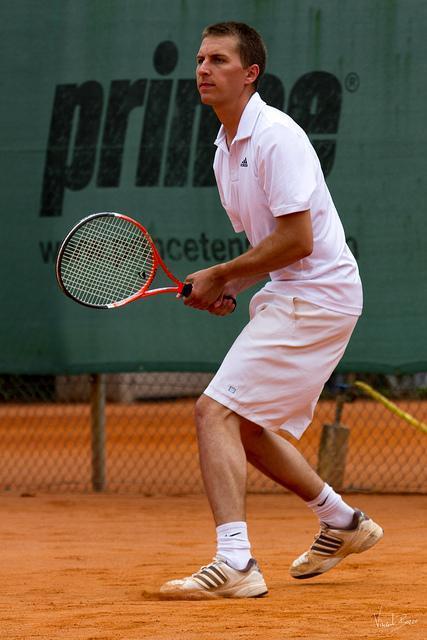How many stripes does each shoe have?
Give a very brief answer. 3. 